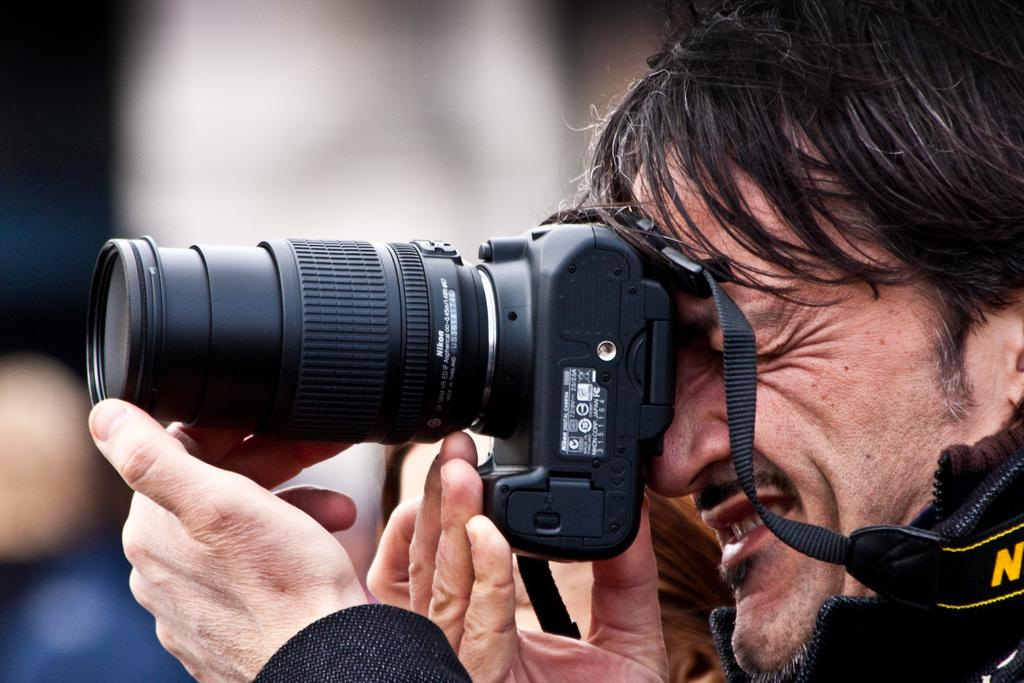Who is the main subject in the image? There is a man in the image. What is the man holding in the image? The man is holding a camera. Can you describe the background of the image? The background of the image is blurry. What type of toothbrush is the man using in the image? There is no toothbrush present in the image; the man is holding a camera. What is the man's destination on his voyage in the image? There is no voyage depicted in the image; it simply shows a man holding a camera with a blurry background. 